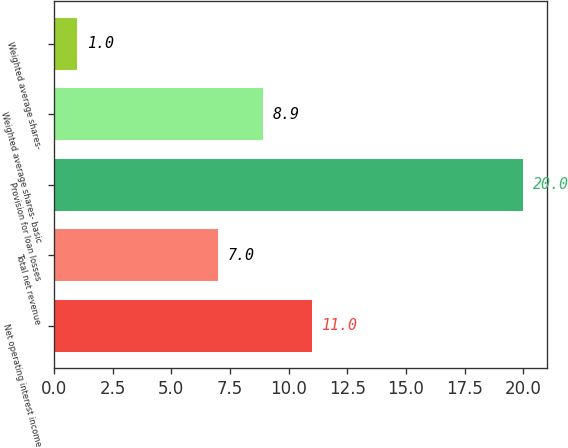<chart> <loc_0><loc_0><loc_500><loc_500><bar_chart><fcel>Net operating interest income<fcel>Total net revenue<fcel>Provision for loan losses<fcel>Weighted average shares- basic<fcel>Weighted average shares-<nl><fcel>11<fcel>7<fcel>20<fcel>8.9<fcel>1<nl></chart> 